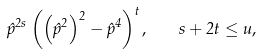<formula> <loc_0><loc_0><loc_500><loc_500>\hat { p } ^ { 2 s } \left ( \left ( \hat { p } ^ { 2 } \right ) ^ { 2 } - \hat { p } ^ { 4 } \right ) ^ { t } , \quad s + 2 t \leq u ,</formula> 